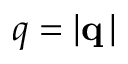Convert formula to latex. <formula><loc_0><loc_0><loc_500><loc_500>q = | { q } \, |</formula> 